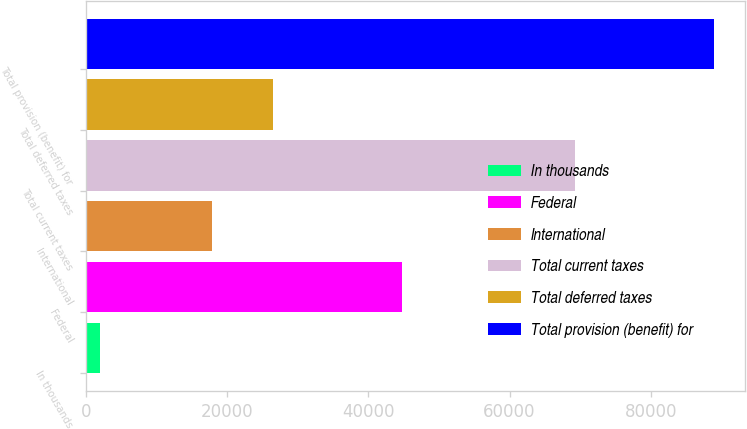<chart> <loc_0><loc_0><loc_500><loc_500><bar_chart><fcel>In thousands<fcel>Federal<fcel>International<fcel>Total current taxes<fcel>Total deferred taxes<fcel>Total provision (benefit) for<nl><fcel>2010<fcel>44766<fcel>17877<fcel>69234<fcel>26570.3<fcel>88943<nl></chart> 